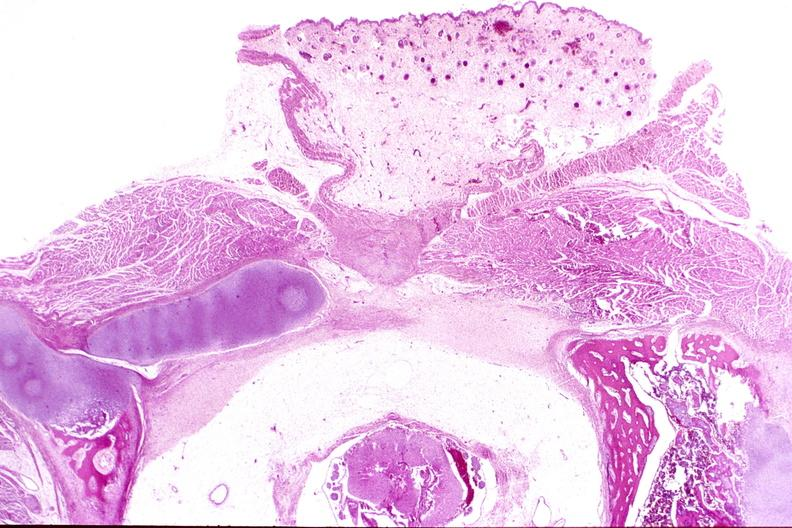does example show neural tube defect, meningomyelocele?
Answer the question using a single word or phrase. No 